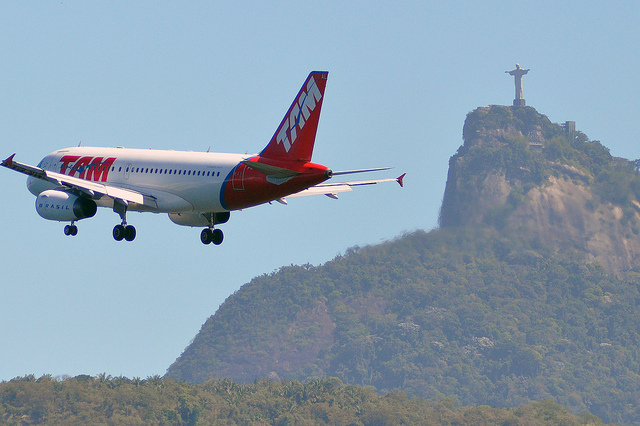Given the direction the airplane is facing, which side of the statue might it pass? The airplane is flying from the left side of the image towards the right. Given its trajectory and position in the image, it appears that the airplane might pass to the left side of the Christ the Redeemer statue as it continues its flight path. 